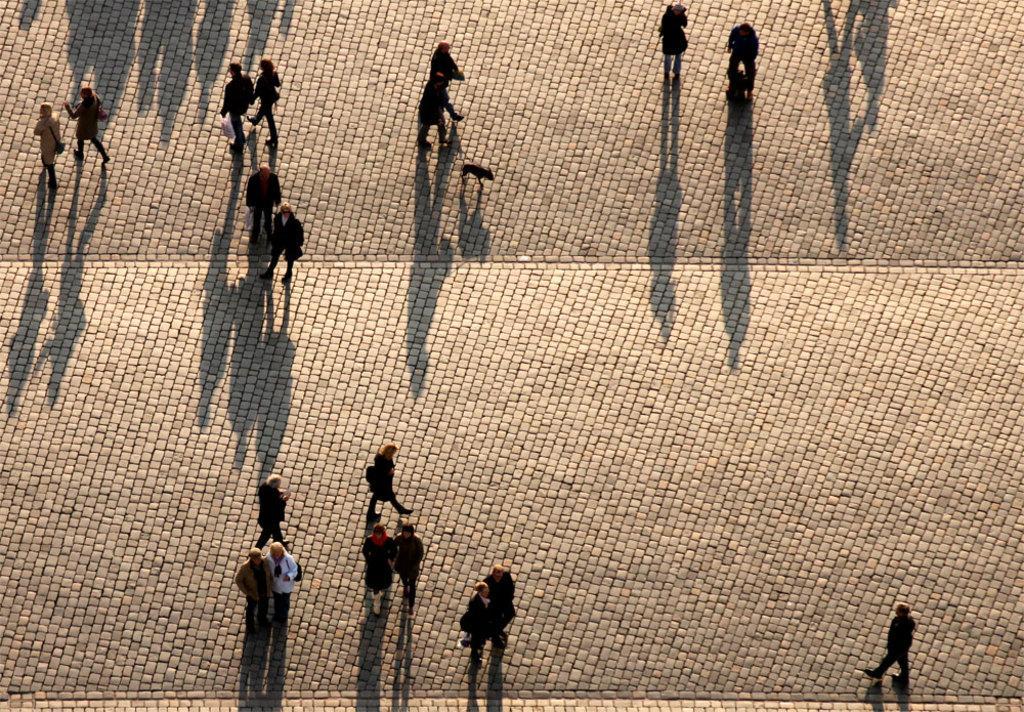How would you summarize this image in a sentence or two? This is the picture taken from the top view and we can see some people and among them few people are walking and few people are standing and there is an animal. 